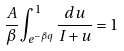<formula> <loc_0><loc_0><loc_500><loc_500>\frac { A } { \beta } \int _ { e ^ { - \beta q } } ^ { 1 } \frac { d u } { I + u } = 1</formula> 